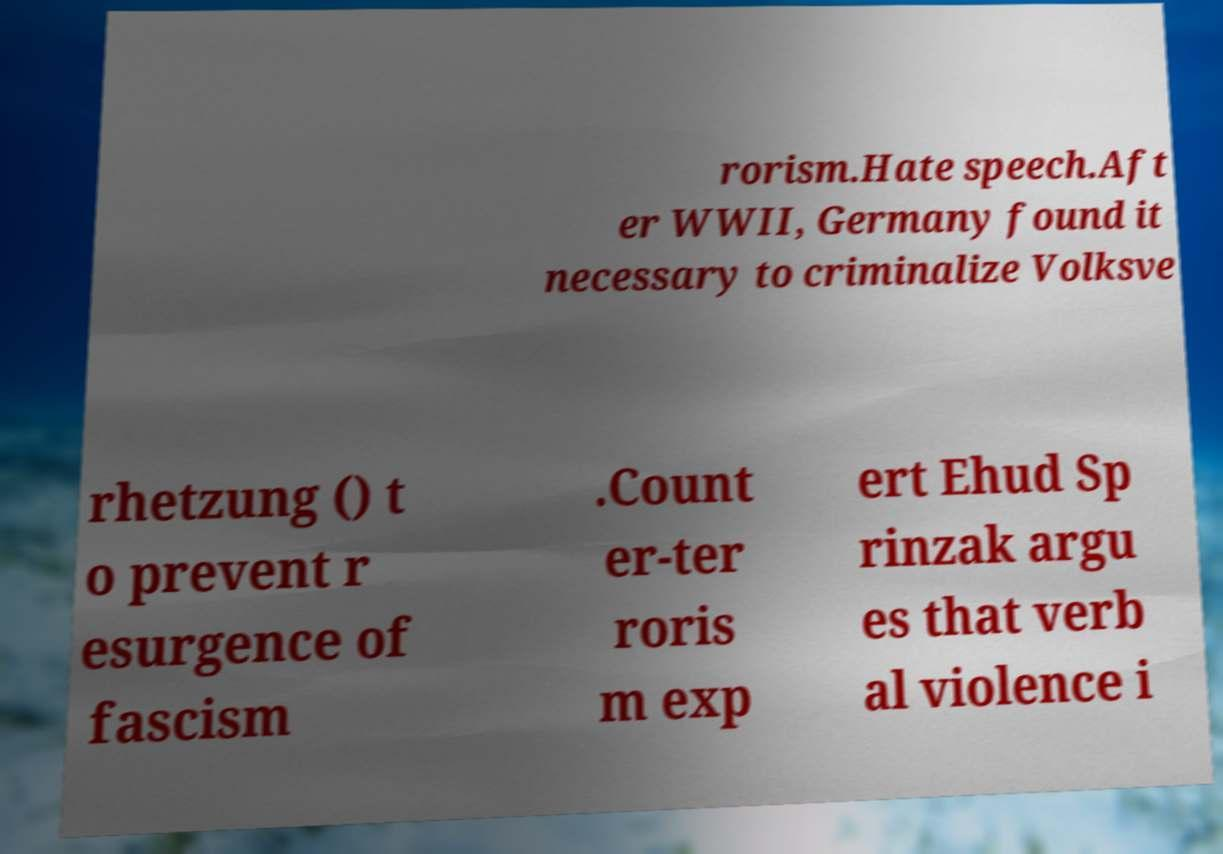Could you extract and type out the text from this image? rorism.Hate speech.Aft er WWII, Germany found it necessary to criminalize Volksve rhetzung () t o prevent r esurgence of fascism .Count er-ter roris m exp ert Ehud Sp rinzak argu es that verb al violence i 